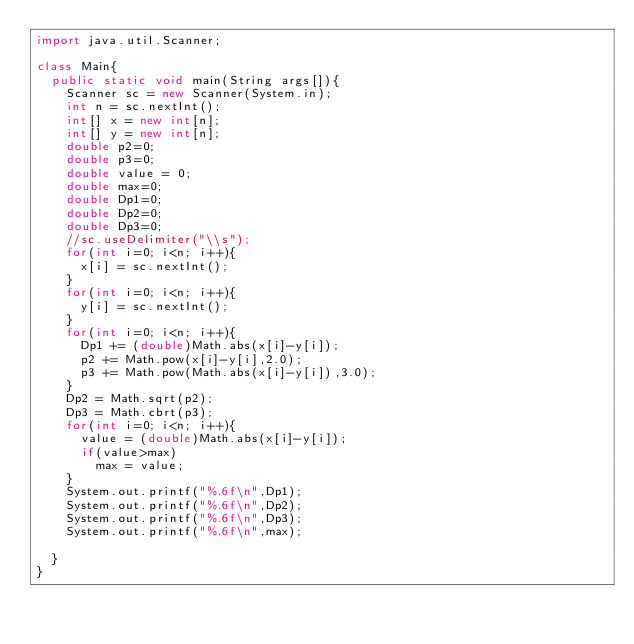<code> <loc_0><loc_0><loc_500><loc_500><_Java_>import java.util.Scanner;

class Main{
	public static void main(String args[]){
		Scanner sc = new Scanner(System.in);
		int n = sc.nextInt();
		int[] x = new int[n];
		int[] y = new int[n];
		double p2=0;
		double p3=0;
		double value = 0;
		double max=0;
		double Dp1=0;
		double Dp2=0;
		double Dp3=0;
		//sc.useDelimiter("\\s");
		for(int i=0; i<n; i++){
			x[i] = sc.nextInt();
		}	
		for(int i=0; i<n; i++){
			y[i] = sc.nextInt();
		}
		for(int i=0; i<n; i++){
			Dp1 += (double)Math.abs(x[i]-y[i]);
			p2 += Math.pow(x[i]-y[i],2.0);
			p3 += Math.pow(Math.abs(x[i]-y[i]),3.0);
		}
		Dp2 = Math.sqrt(p2);
		Dp3 = Math.cbrt(p3);		
		for(int i=0; i<n; i++){
			value = (double)Math.abs(x[i]-y[i]);
			if(value>max)
				max = value;
		}
		System.out.printf("%.6f\n",Dp1);
		System.out.printf("%.6f\n",Dp2);
		System.out.printf("%.6f\n",Dp3);
		System.out.printf("%.6f\n",max);

	}
}</code> 